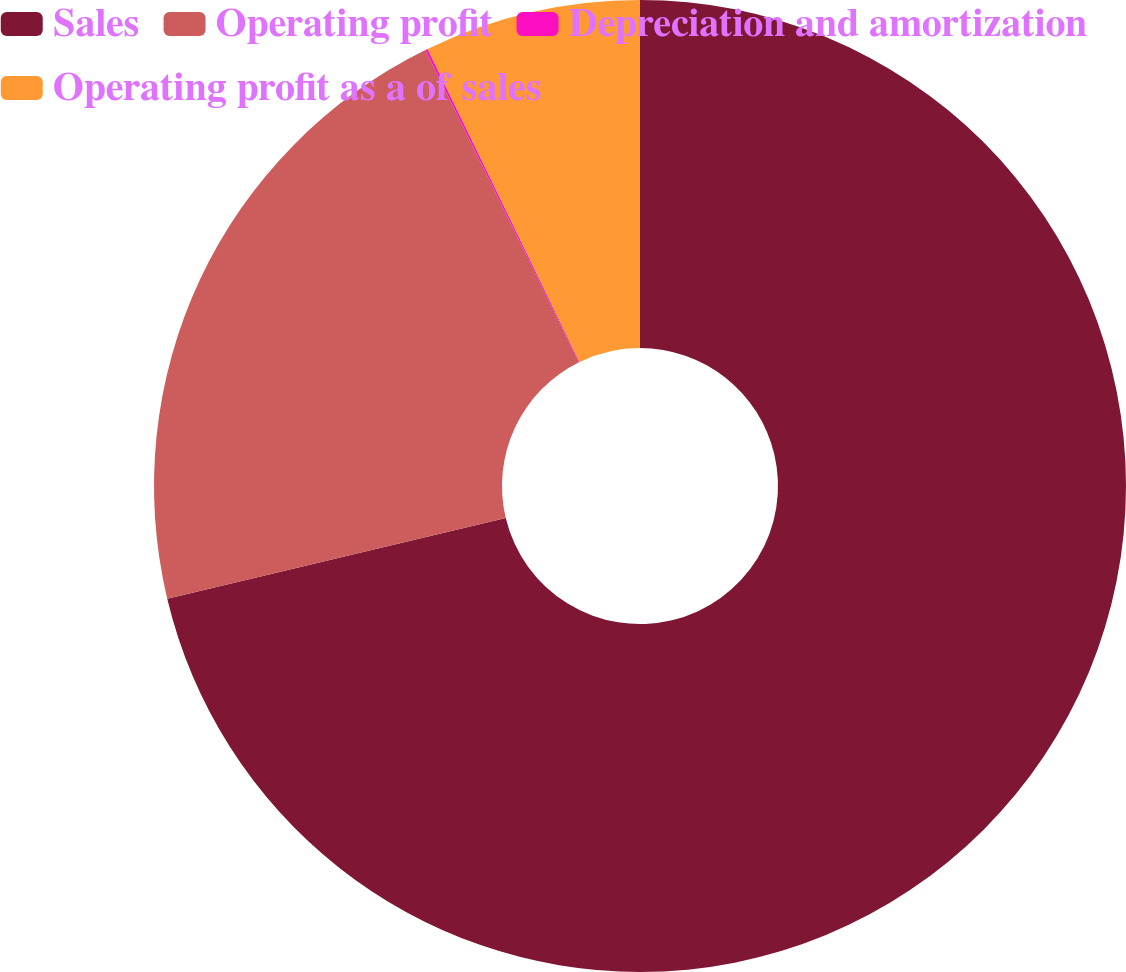<chart> <loc_0><loc_0><loc_500><loc_500><pie_chart><fcel>Sales<fcel>Operating profit<fcel>Depreciation and amortization<fcel>Operating profit as a of sales<nl><fcel>71.27%<fcel>21.44%<fcel>0.08%<fcel>7.2%<nl></chart> 